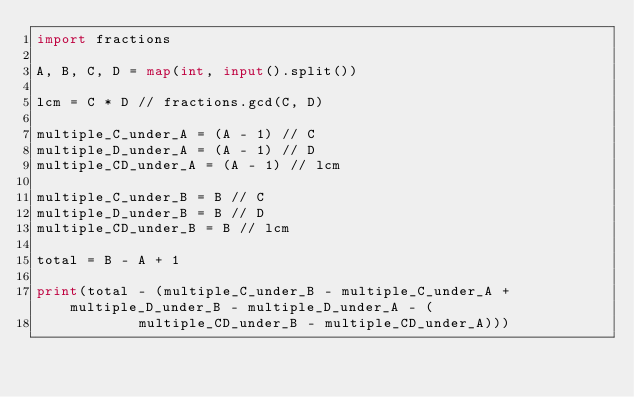<code> <loc_0><loc_0><loc_500><loc_500><_Python_>import fractions

A, B, C, D = map(int, input().split())

lcm = C * D // fractions.gcd(C, D)

multiple_C_under_A = (A - 1) // C
multiple_D_under_A = (A - 1) // D
multiple_CD_under_A = (A - 1) // lcm

multiple_C_under_B = B // C
multiple_D_under_B = B // D
multiple_CD_under_B = B // lcm

total = B - A + 1

print(total - (multiple_C_under_B - multiple_C_under_A + multiple_D_under_B - multiple_D_under_A - (
            multiple_CD_under_B - multiple_CD_under_A)))
</code> 